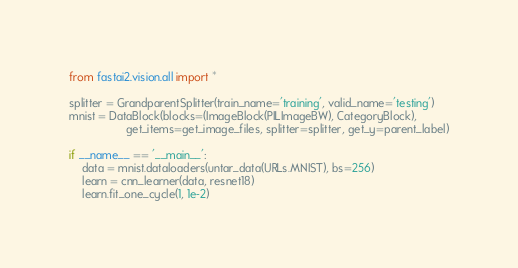<code> <loc_0><loc_0><loc_500><loc_500><_Python_>from fastai2.vision.all import *

splitter = GrandparentSplitter(train_name='training', valid_name='testing')
mnist = DataBlock(blocks=(ImageBlock(PILImageBW), CategoryBlock),
                  get_items=get_image_files, splitter=splitter, get_y=parent_label)

if __name__ == '__main__':
    data = mnist.dataloaders(untar_data(URLs.MNIST), bs=256)
    learn = cnn_learner(data, resnet18)
    learn.fit_one_cycle(1, 1e-2)

</code> 